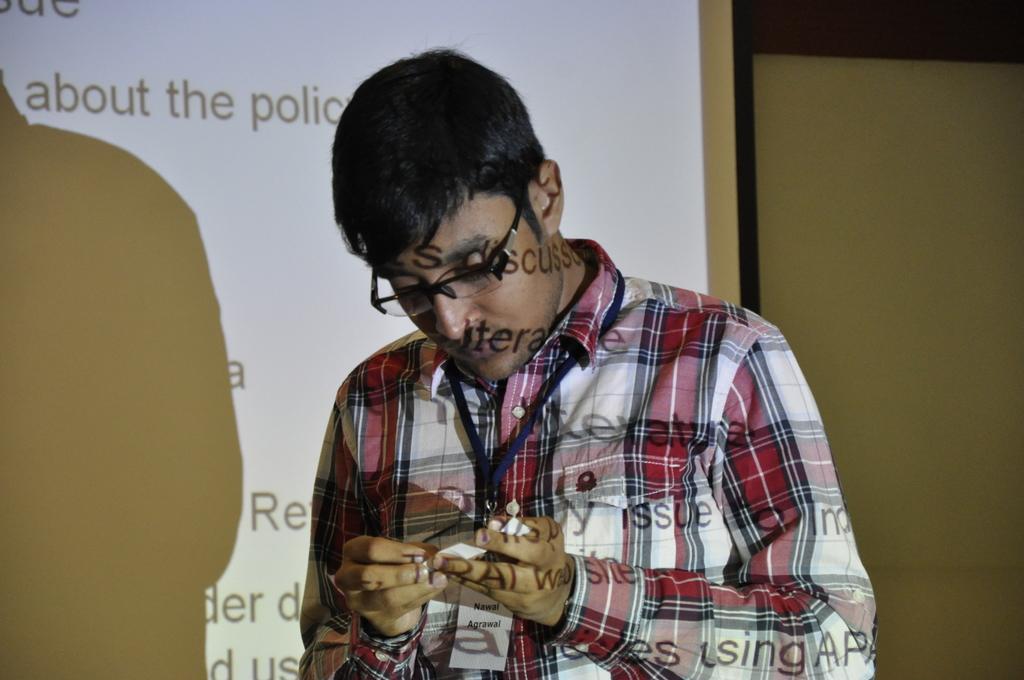Describe this image in one or two sentences. In this picture we can see a man wearing spectacles and holding a paper. We can see the reflection of letters on his body. In the background we can see a projector screen. 